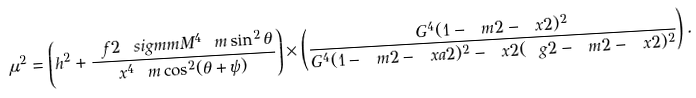Convert formula to latex. <formula><loc_0><loc_0><loc_500><loc_500>\mu ^ { 2 } = \left ( h ^ { 2 } + \frac { \ f 2 \ s i g m m M ^ { 4 } \ m \sin ^ { 2 } \theta } { x ^ { 4 } \ m \cos ^ { 2 } ( \theta + \psi ) } \right ) \times \left ( \frac { G ^ { 4 } ( 1 - \ m 2 - \ x 2 ) ^ { 2 } } { G ^ { 4 } ( 1 - \ m 2 - \ x a 2 ) ^ { 2 } - \ x 2 ( \ g 2 - \ m 2 - \ x 2 ) ^ { 2 } } \right ) .</formula> 